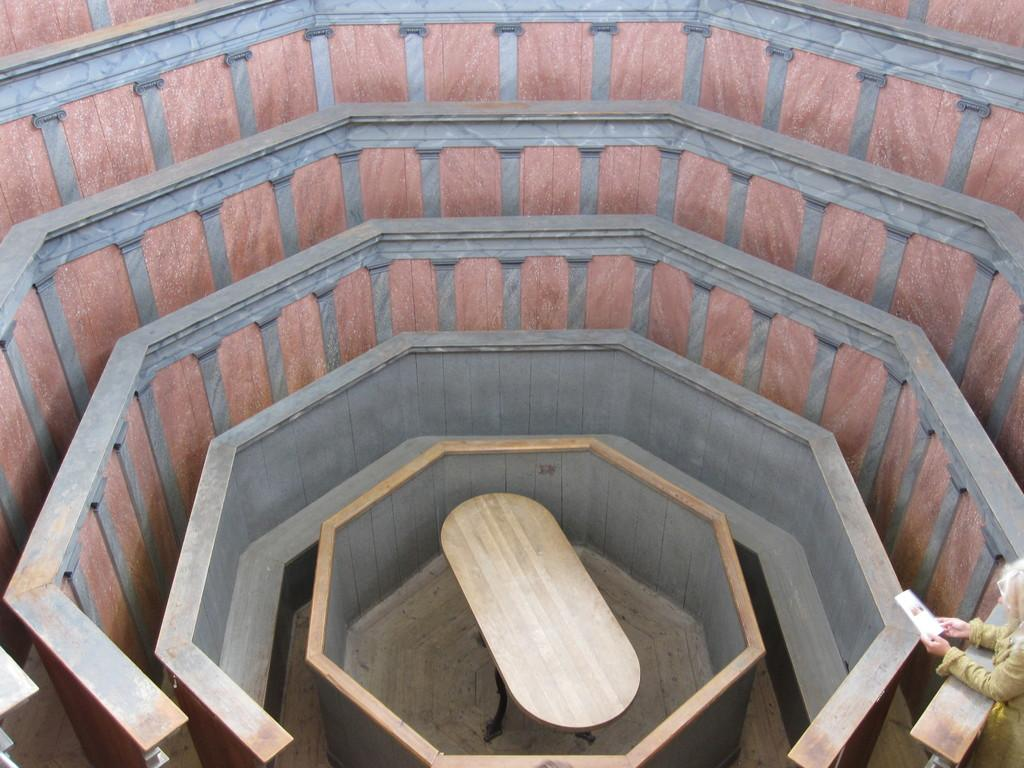What is the main structure in the center of the image? There is a building in the center of the image. What can be seen in the background of the image? There is a wall in the image. What type of furniture is present in the image? There is a wooden table in the image. Who is in the image? There is a person standing in the image. What is the person holding? The person is holding an object. What other items can be seen in the image? There are other objects present in the image. What type of twig is the person using to improve their health in the image? There is no twig or indication of health improvement in the image. 